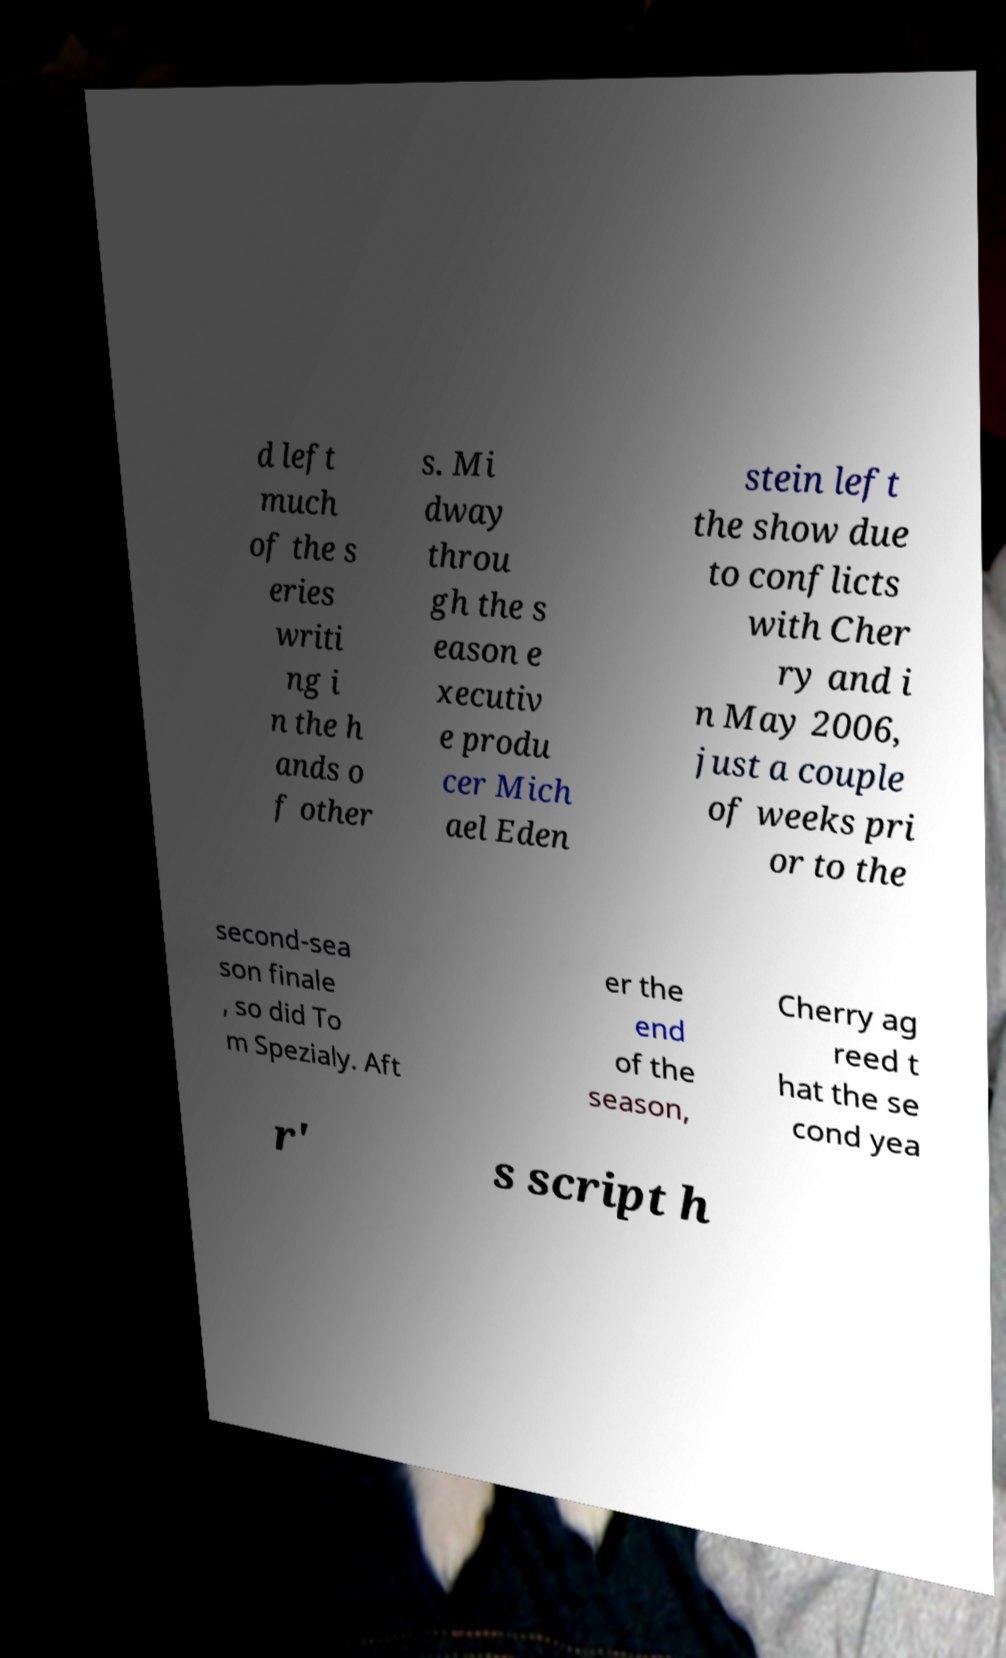Please read and relay the text visible in this image. What does it say? d left much of the s eries writi ng i n the h ands o f other s. Mi dway throu gh the s eason e xecutiv e produ cer Mich ael Eden stein left the show due to conflicts with Cher ry and i n May 2006, just a couple of weeks pri or to the second-sea son finale , so did To m Spezialy. Aft er the end of the season, Cherry ag reed t hat the se cond yea r' s script h 